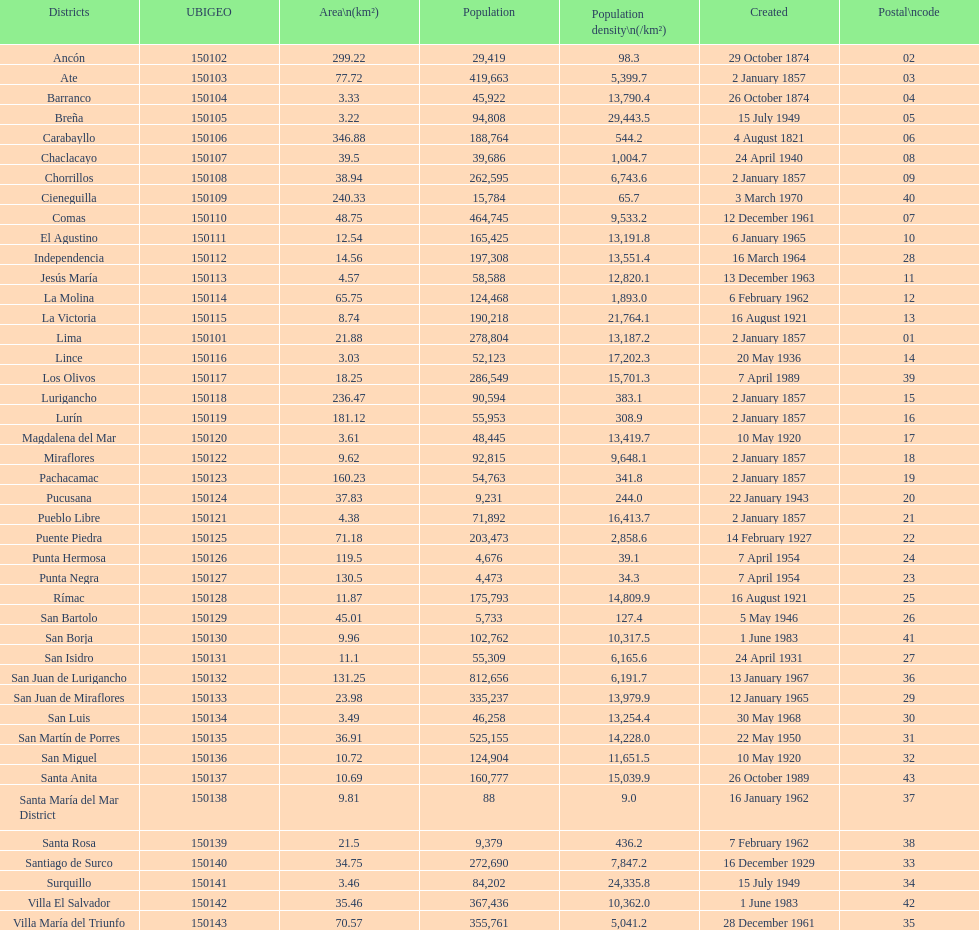Which region possesses the smallest number of inhabitants? Santa María del Mar District. 